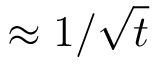Convert formula to latex. <formula><loc_0><loc_0><loc_500><loc_500>\approx 1 / \sqrt { t }</formula> 